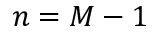Convert formula to latex. <formula><loc_0><loc_0><loc_500><loc_500>n = M - 1</formula> 